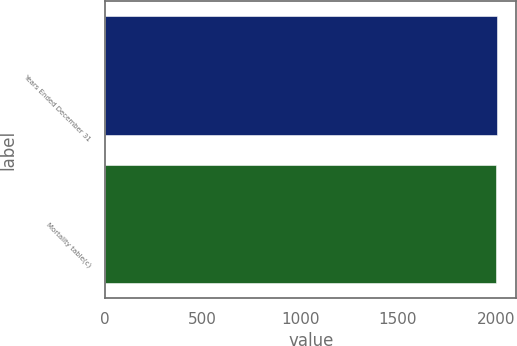Convert chart. <chart><loc_0><loc_0><loc_500><loc_500><bar_chart><fcel>Years Ended December 31<fcel>Mortality table(c)<nl><fcel>2006<fcel>2000<nl></chart> 